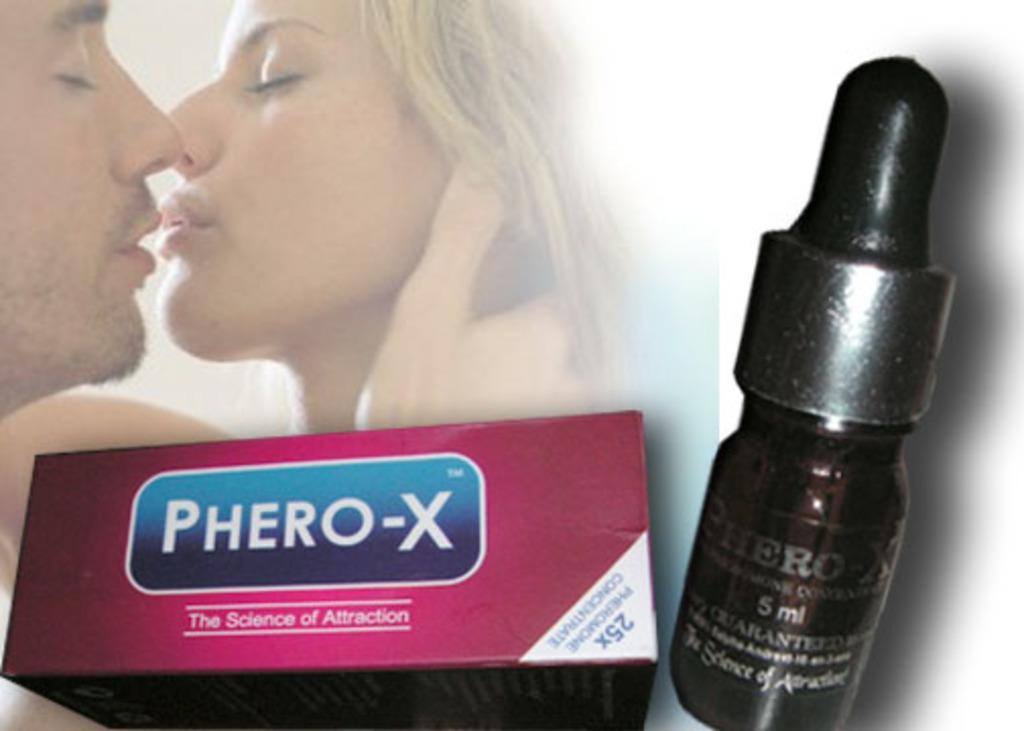In one or two sentences, can you explain what this image depicts? This image consists of a poster. Here I can see a woman and a man. At the bottom of the image I can see a pink color box and a black color bottle. 